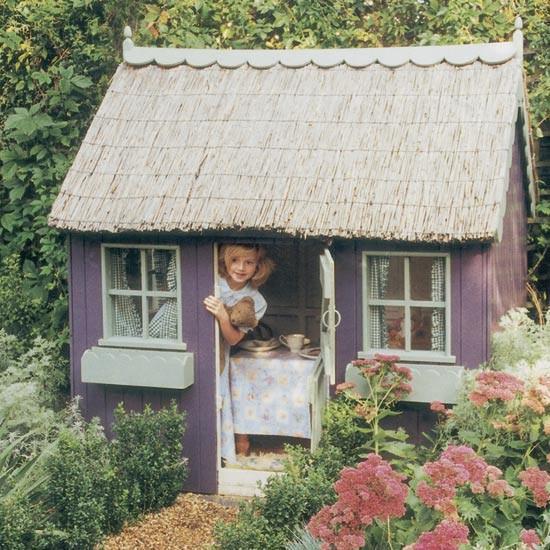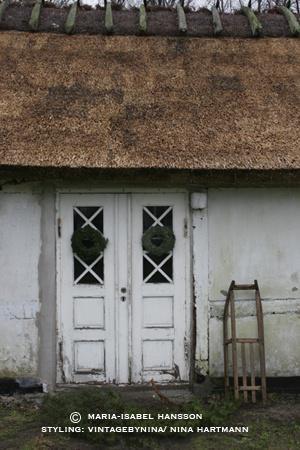The first image is the image on the left, the second image is the image on the right. Given the left and right images, does the statement "The structures on the left and right are simple boxy shapes with peaked thatch roofs featuring some kind of top border, but no curves or notches." hold true? Answer yes or no. Yes. The first image is the image on the left, the second image is the image on the right. Assess this claim about the two images: "One of the houses has posts at the edge of its roof.". Correct or not? Answer yes or no. Yes. 